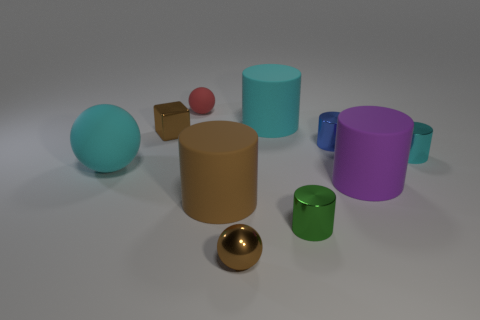There is a matte thing that is the same color as the cube; what shape is it?
Offer a very short reply. Cylinder. The other tiny thing that is the same shape as the red matte thing is what color?
Provide a short and direct response. Brown. Are there any tiny purple shiny objects of the same shape as the small red object?
Offer a terse response. No. What number of things are red matte things or balls that are in front of the blue metal cylinder?
Offer a terse response. 3. What is the color of the sphere that is right of the small rubber sphere?
Provide a short and direct response. Brown. Do the rubber thing that is on the right side of the tiny green thing and the rubber cylinder that is in front of the big purple cylinder have the same size?
Give a very brief answer. Yes. Is there a cylinder that has the same size as the purple thing?
Provide a short and direct response. Yes. There is a cyan thing on the left side of the small red matte ball; how many tiny brown spheres are to the right of it?
Offer a terse response. 1. What is the small cyan thing made of?
Your response must be concise. Metal. What number of small cyan things are in front of the cyan shiny cylinder?
Offer a terse response. 0. 